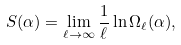Convert formula to latex. <formula><loc_0><loc_0><loc_500><loc_500>S ( \alpha ) = \lim _ { \ell \rightarrow \infty } \frac { 1 } { \ell } \ln { \Omega _ { \ell } ( \alpha ) } ,</formula> 